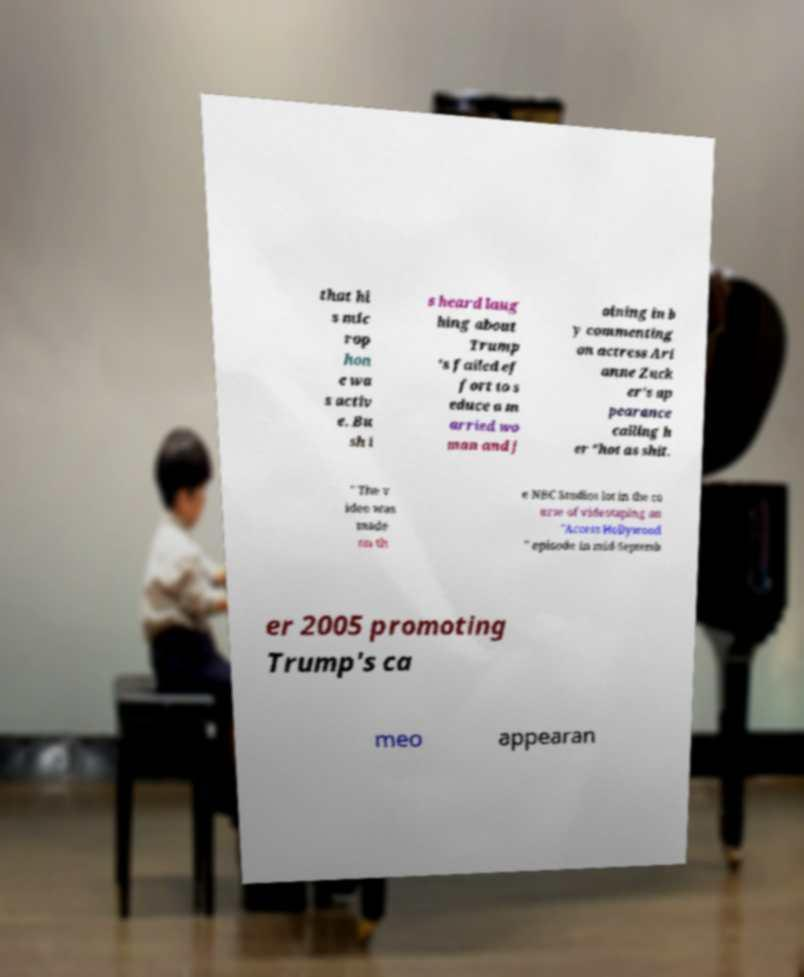What messages or text are displayed in this image? I need them in a readable, typed format. that hi s mic rop hon e wa s activ e. Bu sh i s heard laug hing about Trump 's failed ef fort to s educe a m arried wo man and j oining in b y commenting on actress Ari anne Zuck er's ap pearance calling h er "hot as shit. " The v ideo was made on th e NBC Studios lot in the co urse of videotaping an "Access Hollywood " episode in mid-Septemb er 2005 promoting Trump's ca meo appearan 